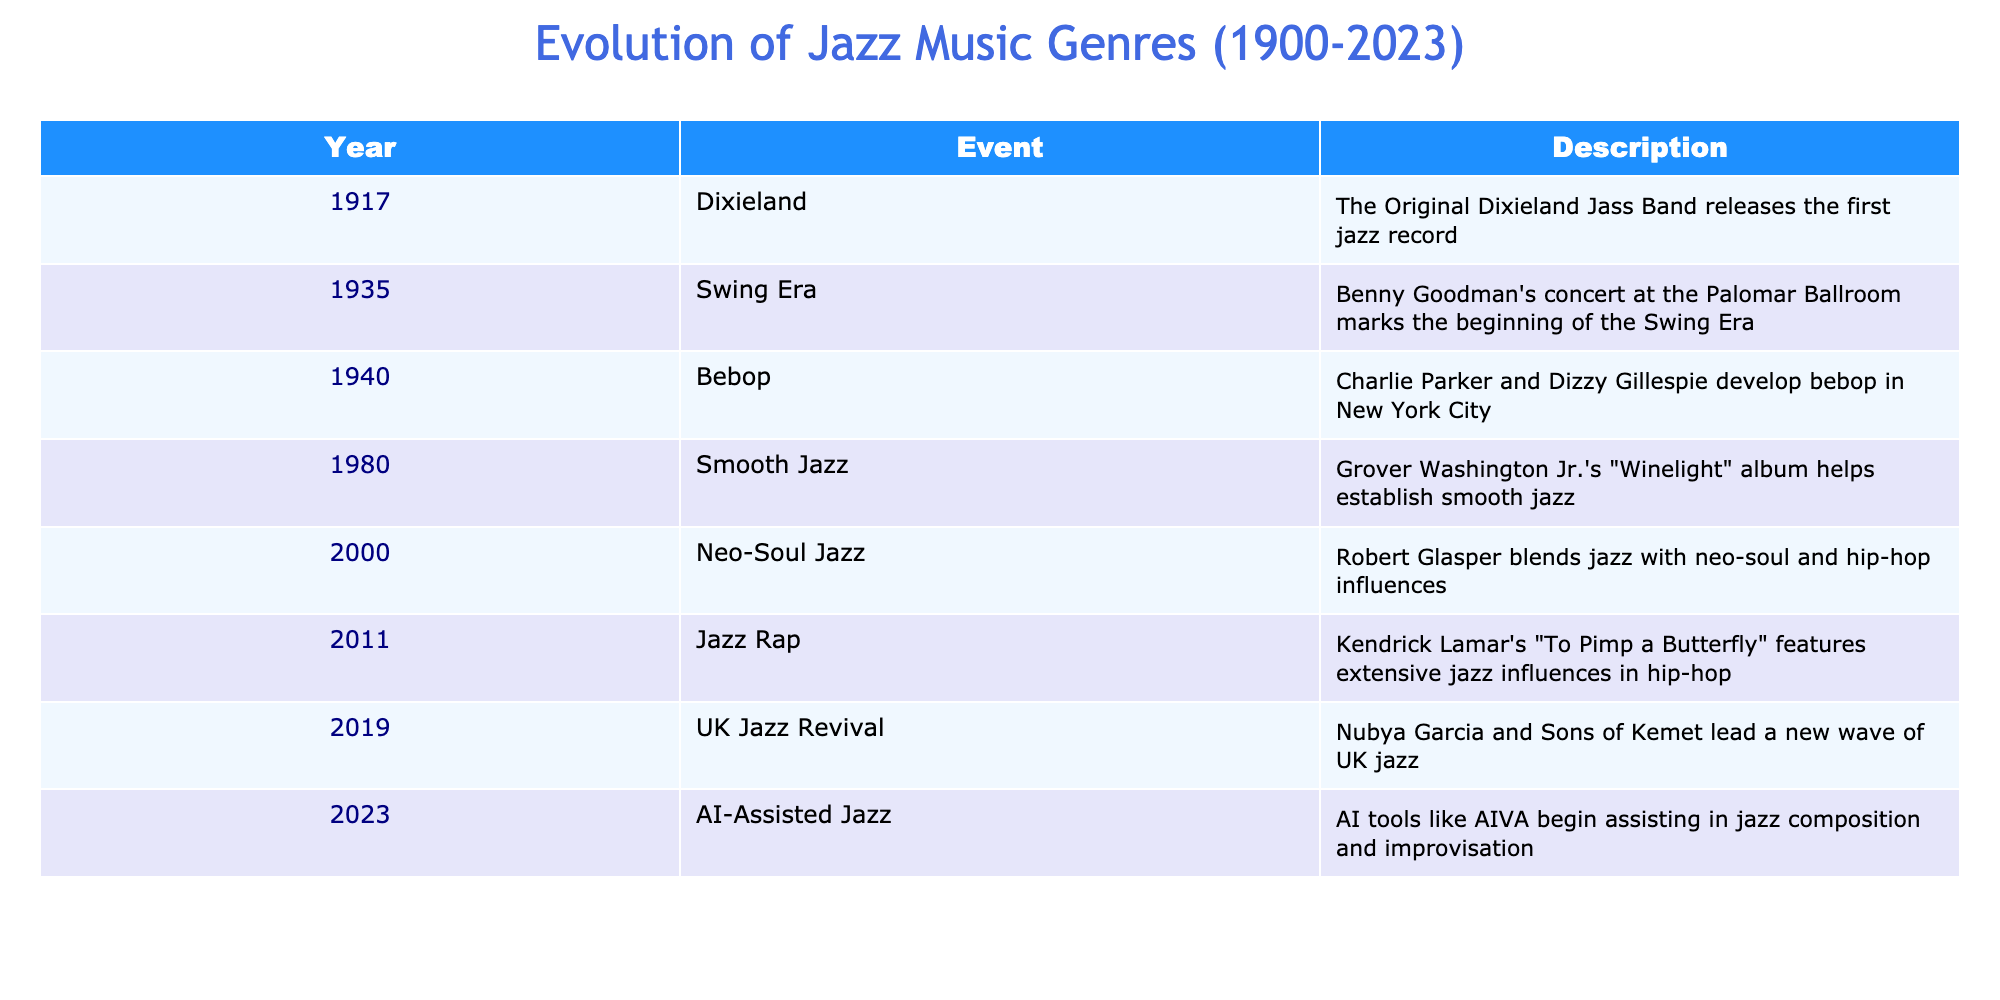What year did the Original Dixieland Jass Band release the first jazz record? The table states that the Original Dixieland Jass Band released the first jazz record in the year 1917.
Answer: 1917 Which event marks the beginning of the Swing Era? According to the table, Benny Goodman's concert at the Palomar Ballroom in 1935 marks the beginning of the Swing Era.
Answer: Benny Goodman's concert at the Palomar Ballroom How many jazz genres are listed in the table for the 20th century? The table lists five jazz genres for the 20th century: Dixieland (1917), Swing Era (1935), Bebop (1940), Smooth Jazz (1980), and Neo-Soul Jazz (2000). Therefore, there are five genres.
Answer: 5 Is AI-assisted jazz mentioned as an event in the timeline? Yes, the table indicates that AI-assisted jazz is listed as an event, occurring in the year 2023.
Answer: Yes Which genre had an influence on Kendrick Lamar's work in 2011? The table specifies that Kendrick Lamar's "To Pimp a Butterfly" features extensive jazz influences and is categorized under Jazz Rap in 2011.
Answer: Jazz Rap What is the difference in years between the introduction of Smooth Jazz and the UK Jazz Revival? Smooth Jazz was introduced in 1980, and the UK Jazz Revival occurred in 2019. The difference is 2019 - 1980 = 39 years.
Answer: 39 years Which genre was developed by Charlie Parker and Dizzy Gillespie? The table notes that Bebop was developed by Charlie Parker and Dizzy Gillespie in the year 1940.
Answer: Bebop How many events occurred in the 21st century, according to the table? The table lists three events that occurred in the 21st century: Neo-Soul Jazz (2000), Jazz Rap (2011), and AI-Assisted Jazz (2023). Therefore, there are three events.
Answer: 3 Is Smooth Jazz introduced after the Swing Era? Yes, the Swing Era began in 1935, while Smooth Jazz was introduced in 1980, which is after the Swing Era.
Answer: Yes What significant development took place in jazz music in 2023? The table indicates that in 2023, AI tools like AIVA began assisting in jazz composition and improvisation, marking a significant development in jazz music.
Answer: AI-assisted jazz composition and improvisation 